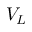Convert formula to latex. <formula><loc_0><loc_0><loc_500><loc_500>V _ { L }</formula> 